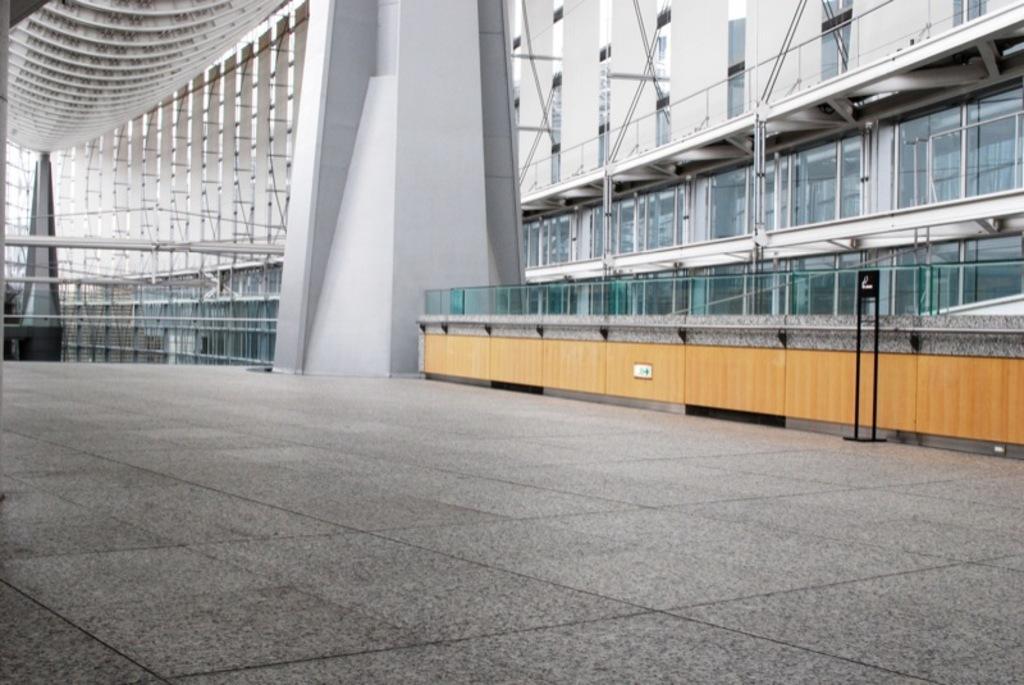Describe this image in one or two sentences. In this picture I can see there is a huge building, there is a pillar, a wooden object at right side and there is a white color frame and it has glass windows, there is a railing at left side. 